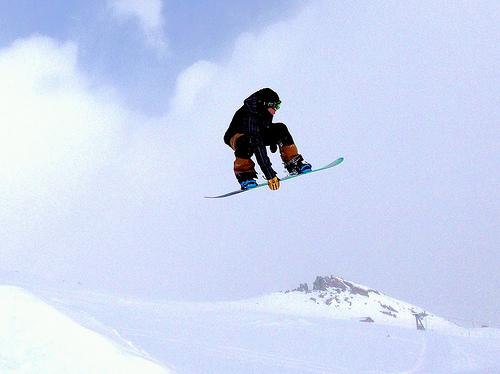Question: what is in the background of this picture?
Choices:
A. Beach.
B. Desert.
C. Buildings.
D. Mountain.
Answer with the letter. Answer: D Question: where was this picture taken?
Choices:
A. Beach.
B. Mountain.
C. Desert.
D. Street.
Answer with the letter. Answer: B Question: what is the man doing?
Choices:
A. Skiing.
B. Snowboarding.
C. Tubing.
D. Sleeding.
Answer with the letter. Answer: B Question: why is the man so high?
Choices:
A. He is doing stunts.
B. He jumped.
C. He is playing.
D. He is skiing.
Answer with the letter. Answer: B Question: what is he grabbing?
Choices:
A. Surfboard.
B. Handle.
C. Snowboard.
D. Bag.
Answer with the letter. Answer: C 